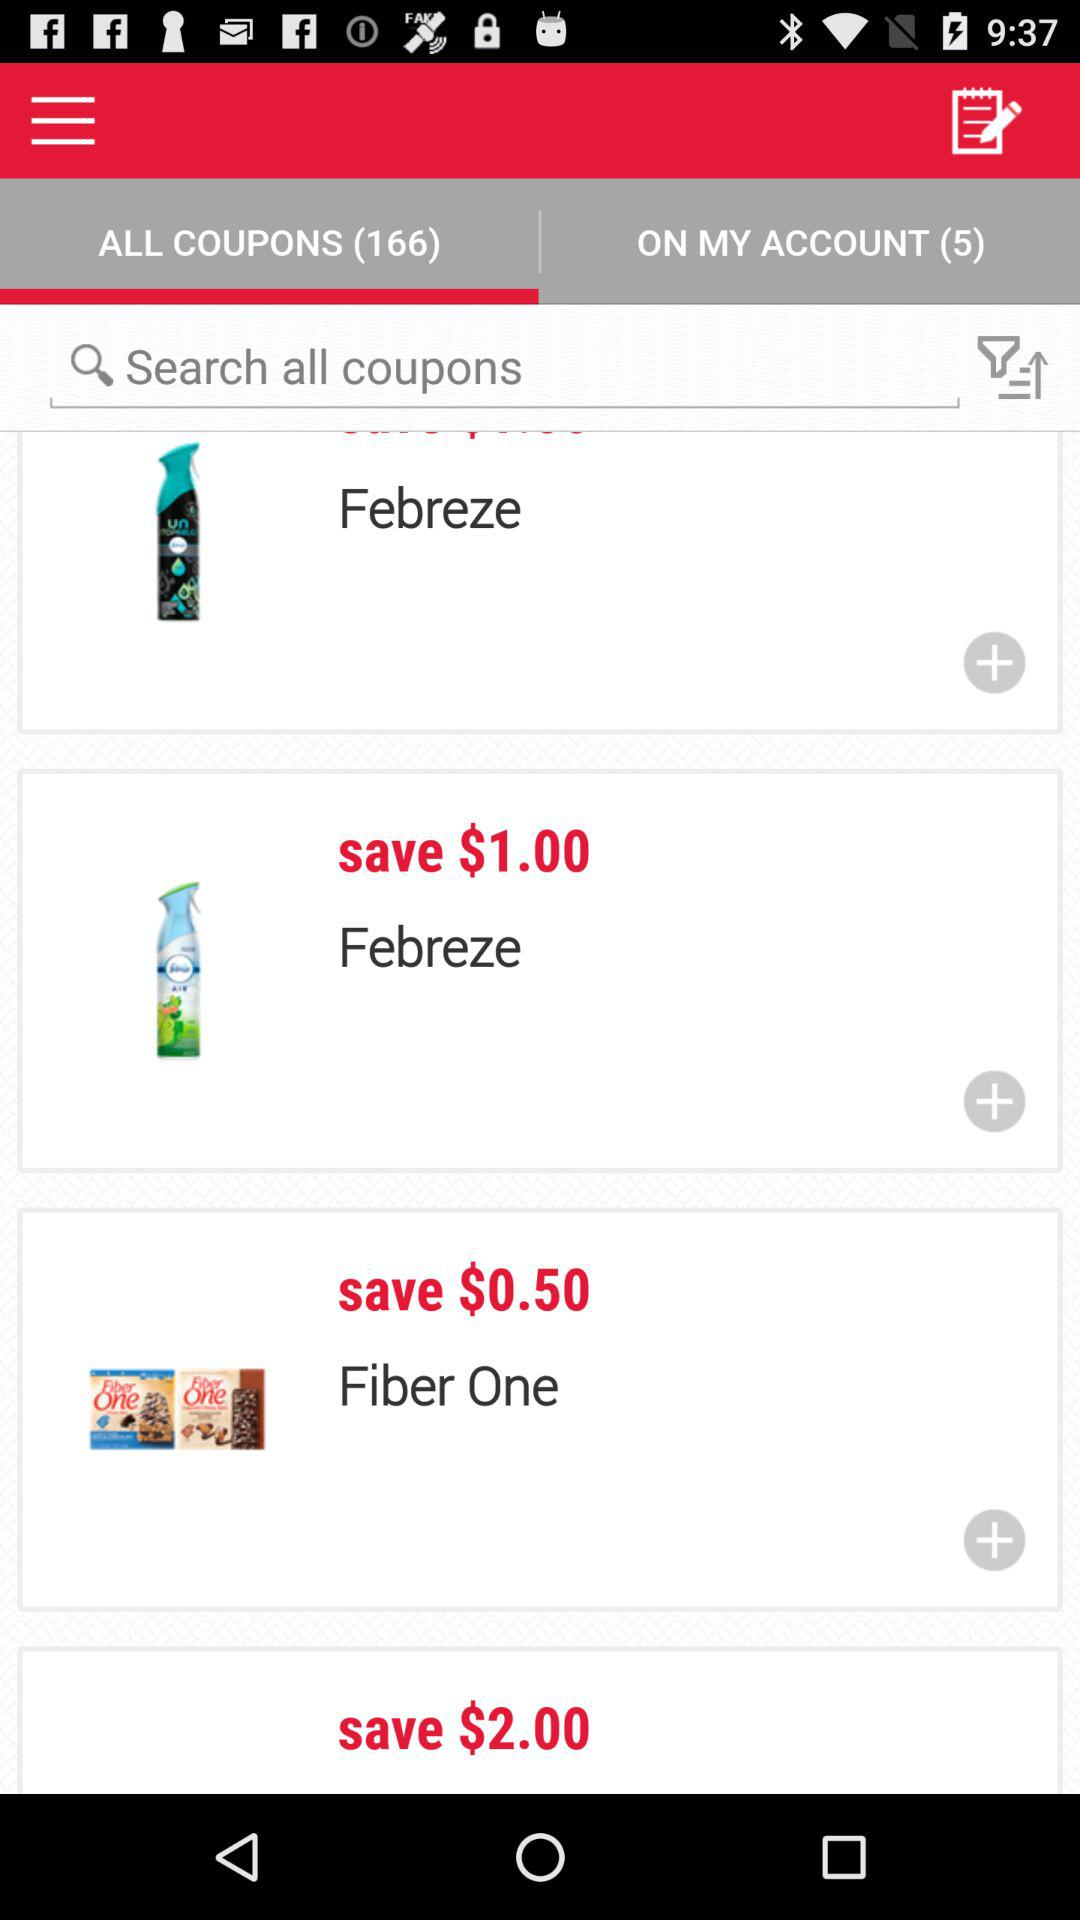How much money can we save on "Fiber One"? You can save $0.50. 